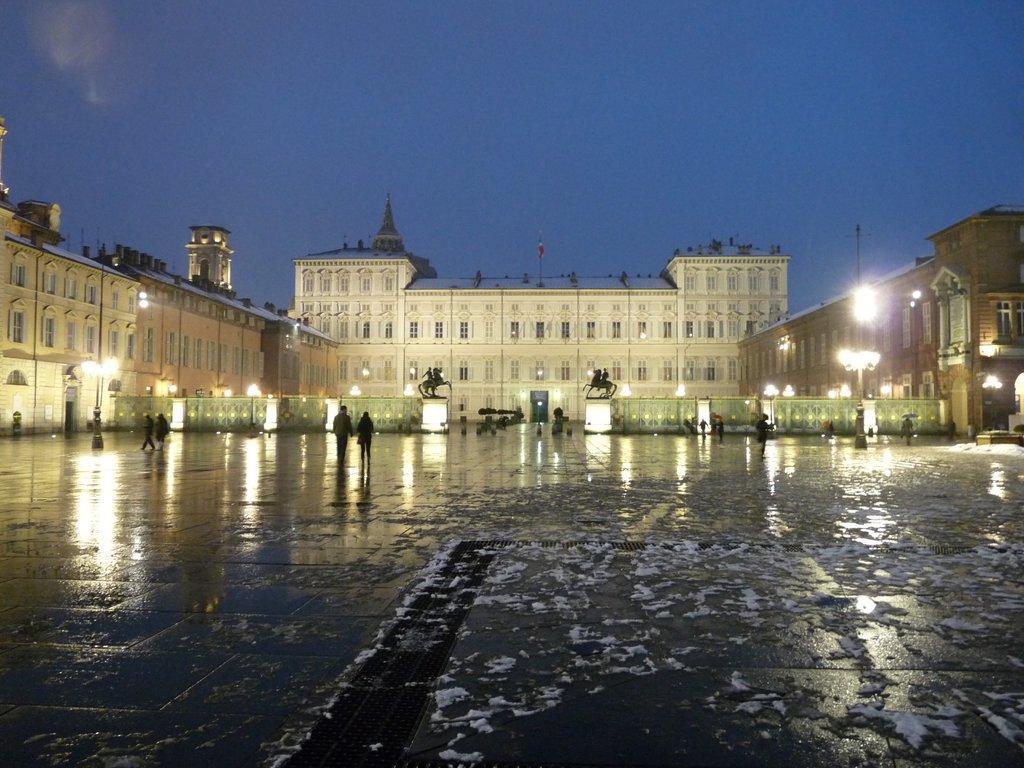In one or two sentences, can you explain what this image depicts? In this picture I can see there is a building in the backdrop and there are few people walking in the front and there are lights arranged to the poles and the sky is clear. 